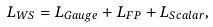<formula> <loc_0><loc_0><loc_500><loc_500>L _ { W S } = L _ { G a u g e } + L _ { F P } + L _ { S c a l a r } ,</formula> 